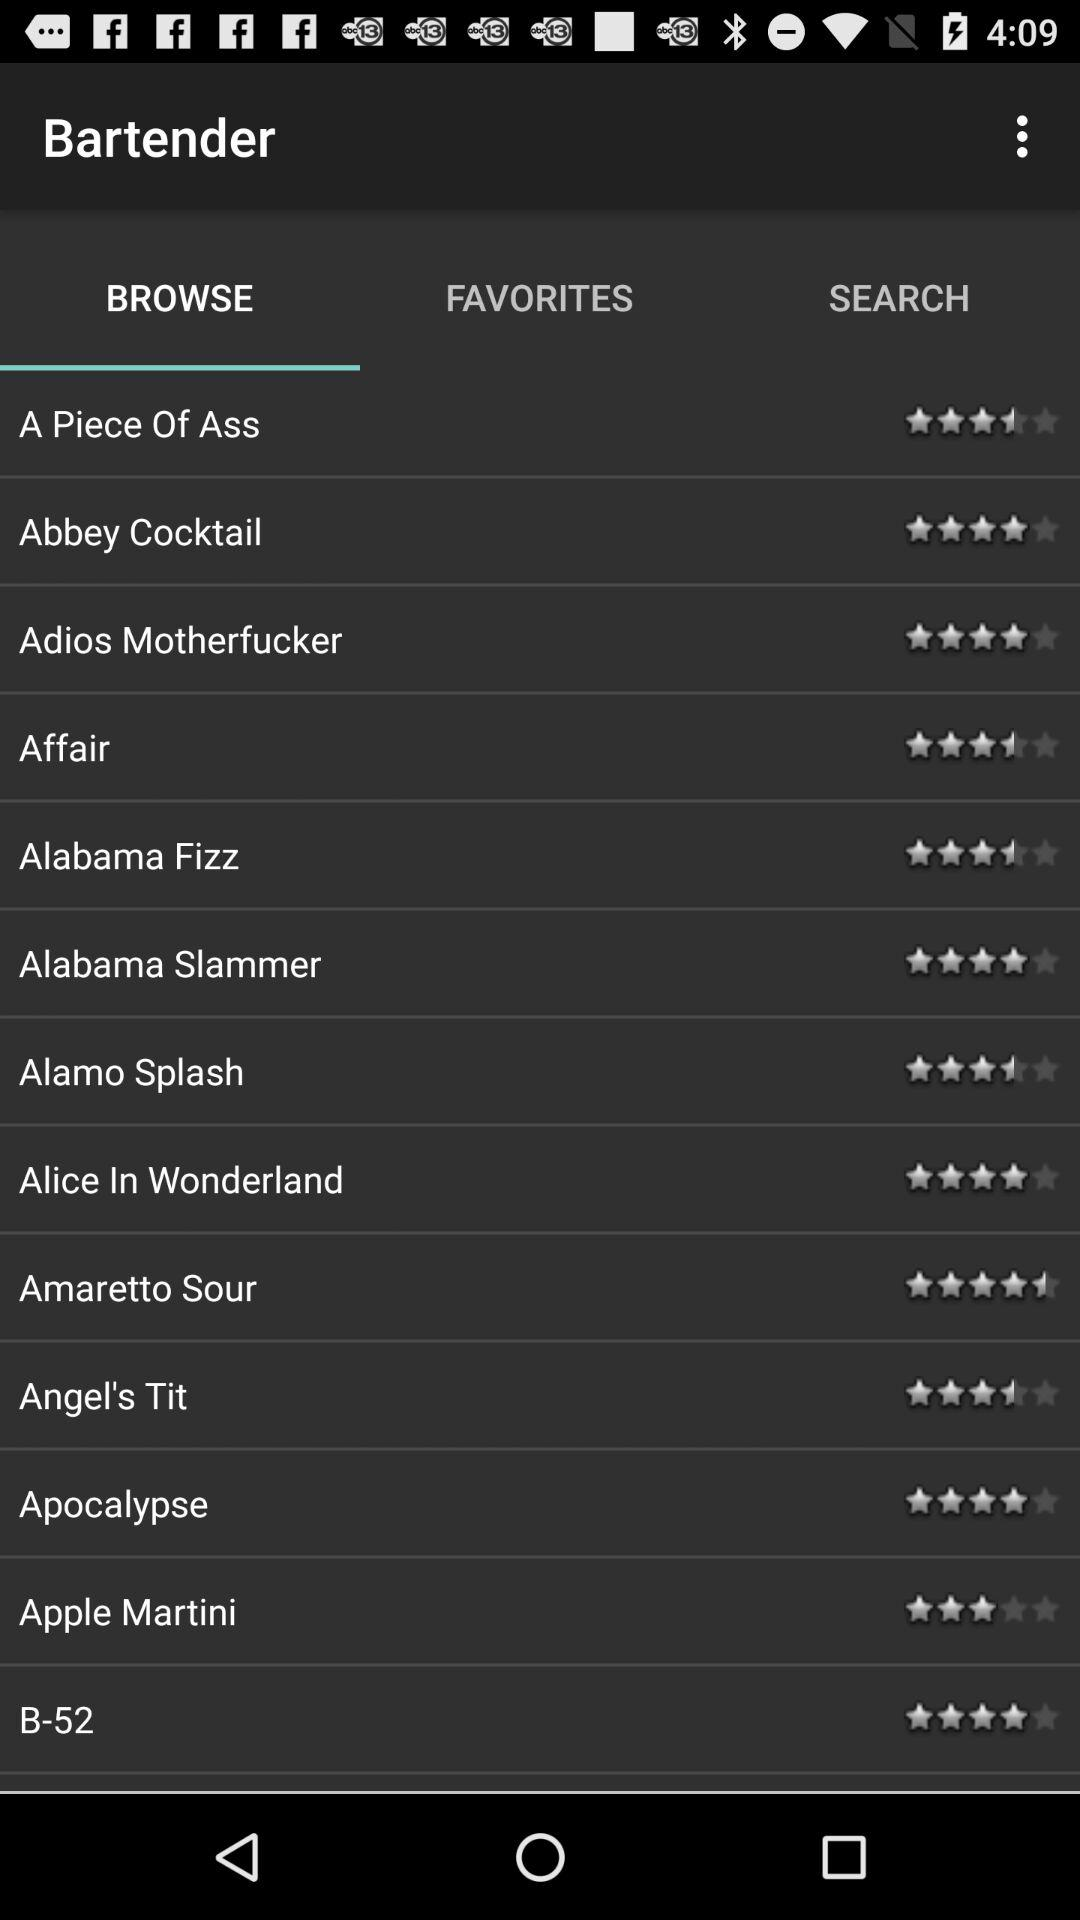What is the rating for "B-52"? The rating for "B-52" is 4 stars. 